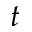Convert formula to latex. <formula><loc_0><loc_0><loc_500><loc_500>t</formula> 